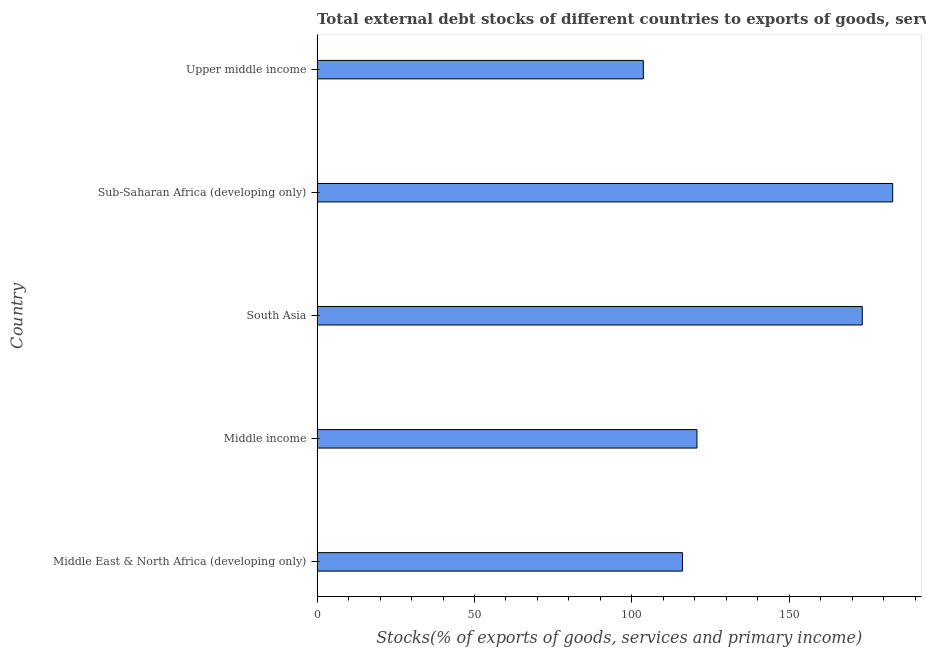Does the graph contain grids?
Provide a succinct answer. No. What is the title of the graph?
Your response must be concise. Total external debt stocks of different countries to exports of goods, services and primary income in 2001. What is the label or title of the X-axis?
Your response must be concise. Stocks(% of exports of goods, services and primary income). What is the label or title of the Y-axis?
Your response must be concise. Country. What is the external debt stocks in Middle income?
Give a very brief answer. 120.66. Across all countries, what is the maximum external debt stocks?
Ensure brevity in your answer.  182.83. Across all countries, what is the minimum external debt stocks?
Give a very brief answer. 103.62. In which country was the external debt stocks maximum?
Provide a short and direct response. Sub-Saharan Africa (developing only). In which country was the external debt stocks minimum?
Offer a very short reply. Upper middle income. What is the sum of the external debt stocks?
Your answer should be very brief. 696.31. What is the difference between the external debt stocks in Middle East & North Africa (developing only) and Upper middle income?
Make the answer very short. 12.41. What is the average external debt stocks per country?
Offer a very short reply. 139.26. What is the median external debt stocks?
Your response must be concise. 120.66. In how many countries, is the external debt stocks greater than 140 %?
Your answer should be very brief. 2. What is the difference between the highest and the second highest external debt stocks?
Make the answer very short. 9.67. Is the sum of the external debt stocks in Middle income and South Asia greater than the maximum external debt stocks across all countries?
Provide a succinct answer. Yes. What is the difference between the highest and the lowest external debt stocks?
Your answer should be compact. 79.21. In how many countries, is the external debt stocks greater than the average external debt stocks taken over all countries?
Keep it short and to the point. 2. How many bars are there?
Your response must be concise. 5. Are all the bars in the graph horizontal?
Your response must be concise. Yes. What is the difference between two consecutive major ticks on the X-axis?
Offer a very short reply. 50. Are the values on the major ticks of X-axis written in scientific E-notation?
Provide a short and direct response. No. What is the Stocks(% of exports of goods, services and primary income) of Middle East & North Africa (developing only)?
Make the answer very short. 116.04. What is the Stocks(% of exports of goods, services and primary income) of Middle income?
Your answer should be very brief. 120.66. What is the Stocks(% of exports of goods, services and primary income) in South Asia?
Provide a succinct answer. 173.16. What is the Stocks(% of exports of goods, services and primary income) in Sub-Saharan Africa (developing only)?
Make the answer very short. 182.83. What is the Stocks(% of exports of goods, services and primary income) in Upper middle income?
Give a very brief answer. 103.62. What is the difference between the Stocks(% of exports of goods, services and primary income) in Middle East & North Africa (developing only) and Middle income?
Give a very brief answer. -4.62. What is the difference between the Stocks(% of exports of goods, services and primary income) in Middle East & North Africa (developing only) and South Asia?
Your response must be concise. -57.12. What is the difference between the Stocks(% of exports of goods, services and primary income) in Middle East & North Africa (developing only) and Sub-Saharan Africa (developing only)?
Make the answer very short. -66.79. What is the difference between the Stocks(% of exports of goods, services and primary income) in Middle East & North Africa (developing only) and Upper middle income?
Offer a terse response. 12.42. What is the difference between the Stocks(% of exports of goods, services and primary income) in Middle income and South Asia?
Your answer should be compact. -52.5. What is the difference between the Stocks(% of exports of goods, services and primary income) in Middle income and Sub-Saharan Africa (developing only)?
Ensure brevity in your answer.  -62.17. What is the difference between the Stocks(% of exports of goods, services and primary income) in Middle income and Upper middle income?
Ensure brevity in your answer.  17.03. What is the difference between the Stocks(% of exports of goods, services and primary income) in South Asia and Sub-Saharan Africa (developing only)?
Your answer should be very brief. -9.67. What is the difference between the Stocks(% of exports of goods, services and primary income) in South Asia and Upper middle income?
Your response must be concise. 69.54. What is the difference between the Stocks(% of exports of goods, services and primary income) in Sub-Saharan Africa (developing only) and Upper middle income?
Offer a terse response. 79.21. What is the ratio of the Stocks(% of exports of goods, services and primary income) in Middle East & North Africa (developing only) to that in Middle income?
Make the answer very short. 0.96. What is the ratio of the Stocks(% of exports of goods, services and primary income) in Middle East & North Africa (developing only) to that in South Asia?
Keep it short and to the point. 0.67. What is the ratio of the Stocks(% of exports of goods, services and primary income) in Middle East & North Africa (developing only) to that in Sub-Saharan Africa (developing only)?
Offer a terse response. 0.64. What is the ratio of the Stocks(% of exports of goods, services and primary income) in Middle East & North Africa (developing only) to that in Upper middle income?
Make the answer very short. 1.12. What is the ratio of the Stocks(% of exports of goods, services and primary income) in Middle income to that in South Asia?
Ensure brevity in your answer.  0.7. What is the ratio of the Stocks(% of exports of goods, services and primary income) in Middle income to that in Sub-Saharan Africa (developing only)?
Ensure brevity in your answer.  0.66. What is the ratio of the Stocks(% of exports of goods, services and primary income) in Middle income to that in Upper middle income?
Ensure brevity in your answer.  1.16. What is the ratio of the Stocks(% of exports of goods, services and primary income) in South Asia to that in Sub-Saharan Africa (developing only)?
Your answer should be compact. 0.95. What is the ratio of the Stocks(% of exports of goods, services and primary income) in South Asia to that in Upper middle income?
Give a very brief answer. 1.67. What is the ratio of the Stocks(% of exports of goods, services and primary income) in Sub-Saharan Africa (developing only) to that in Upper middle income?
Offer a terse response. 1.76. 